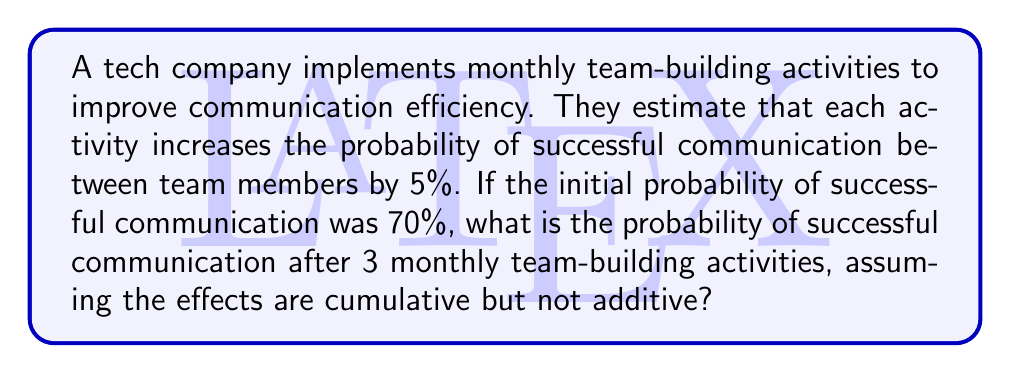Could you help me with this problem? To solve this problem, we need to follow these steps:

1. Understand the initial probability of successful communication:
   $P_0 = 70\% = 0.70$

2. Calculate the improvement factor for each team-building activity:
   Improvement factor = $1 + 5\% = 1.05$

3. Apply the improvement factor cumulatively for 3 months:
   $P_3 = P_0 \times (1.05)^3$

4. Calculate the final probability:
   $P_3 = 0.70 \times (1.05)^3$
   $P_3 = 0.70 \times 1.157625$
   $P_3 = 0.810337500$

5. Convert the result to a percentage:
   $P_3 = 81.03375\%$

Therefore, after 3 monthly team-building activities, the probability of successful communication increases to approximately 81.03%.
Answer: 81.03% 